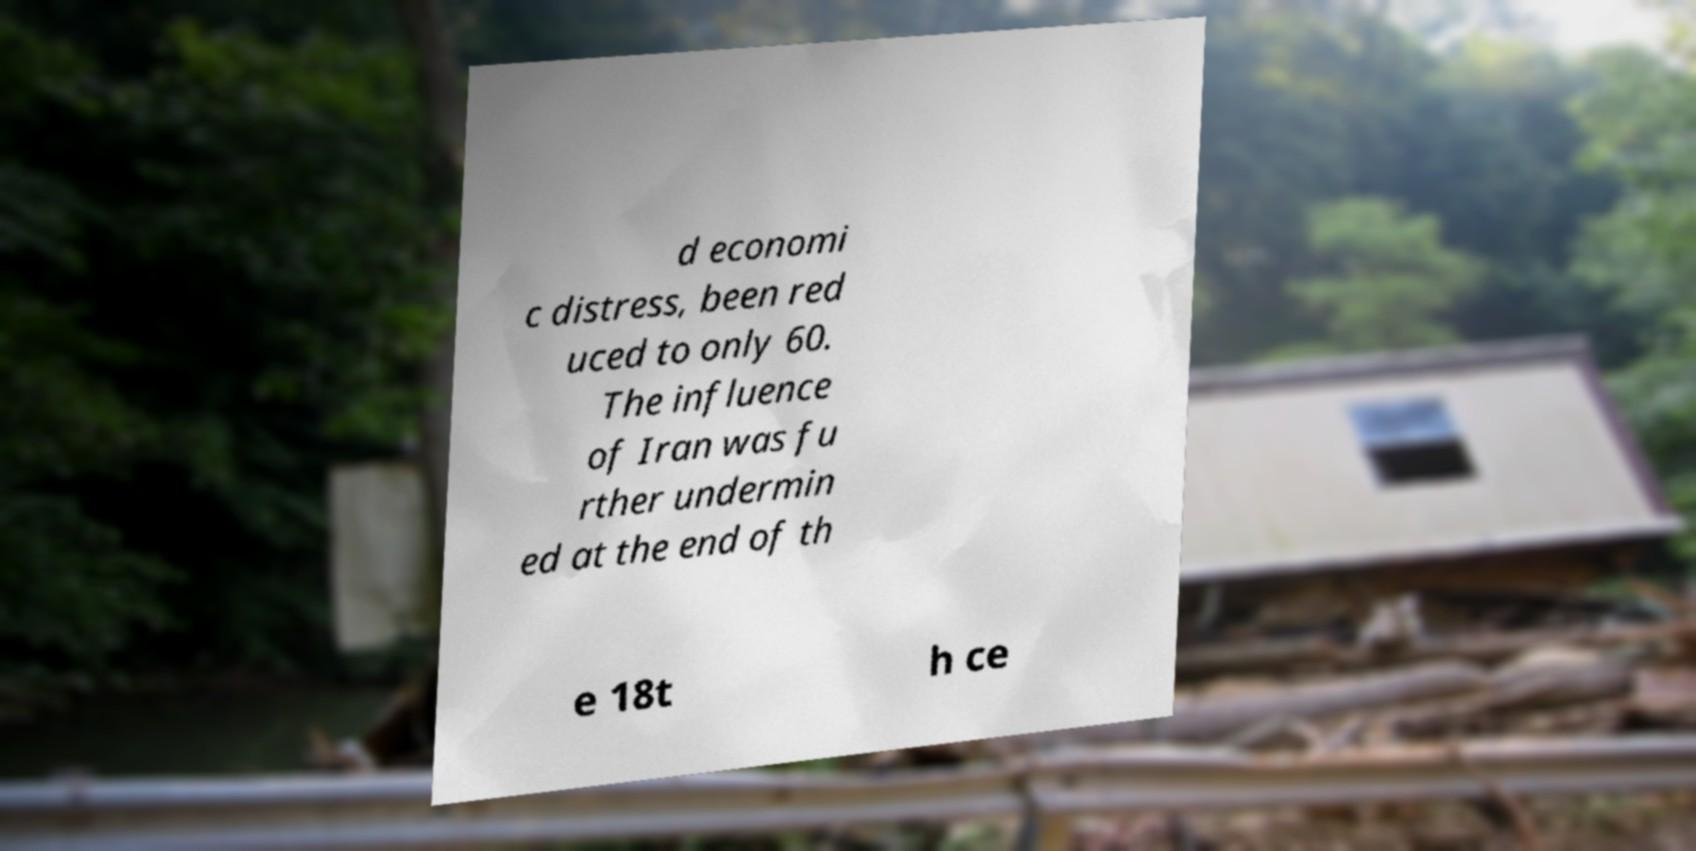Please identify and transcribe the text found in this image. d economi c distress, been red uced to only 60. The influence of Iran was fu rther undermin ed at the end of th e 18t h ce 